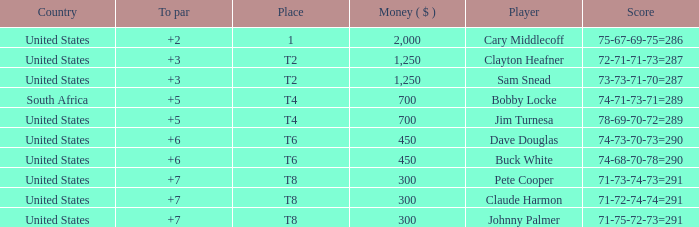What is Claude Harmon's Place? T8. 